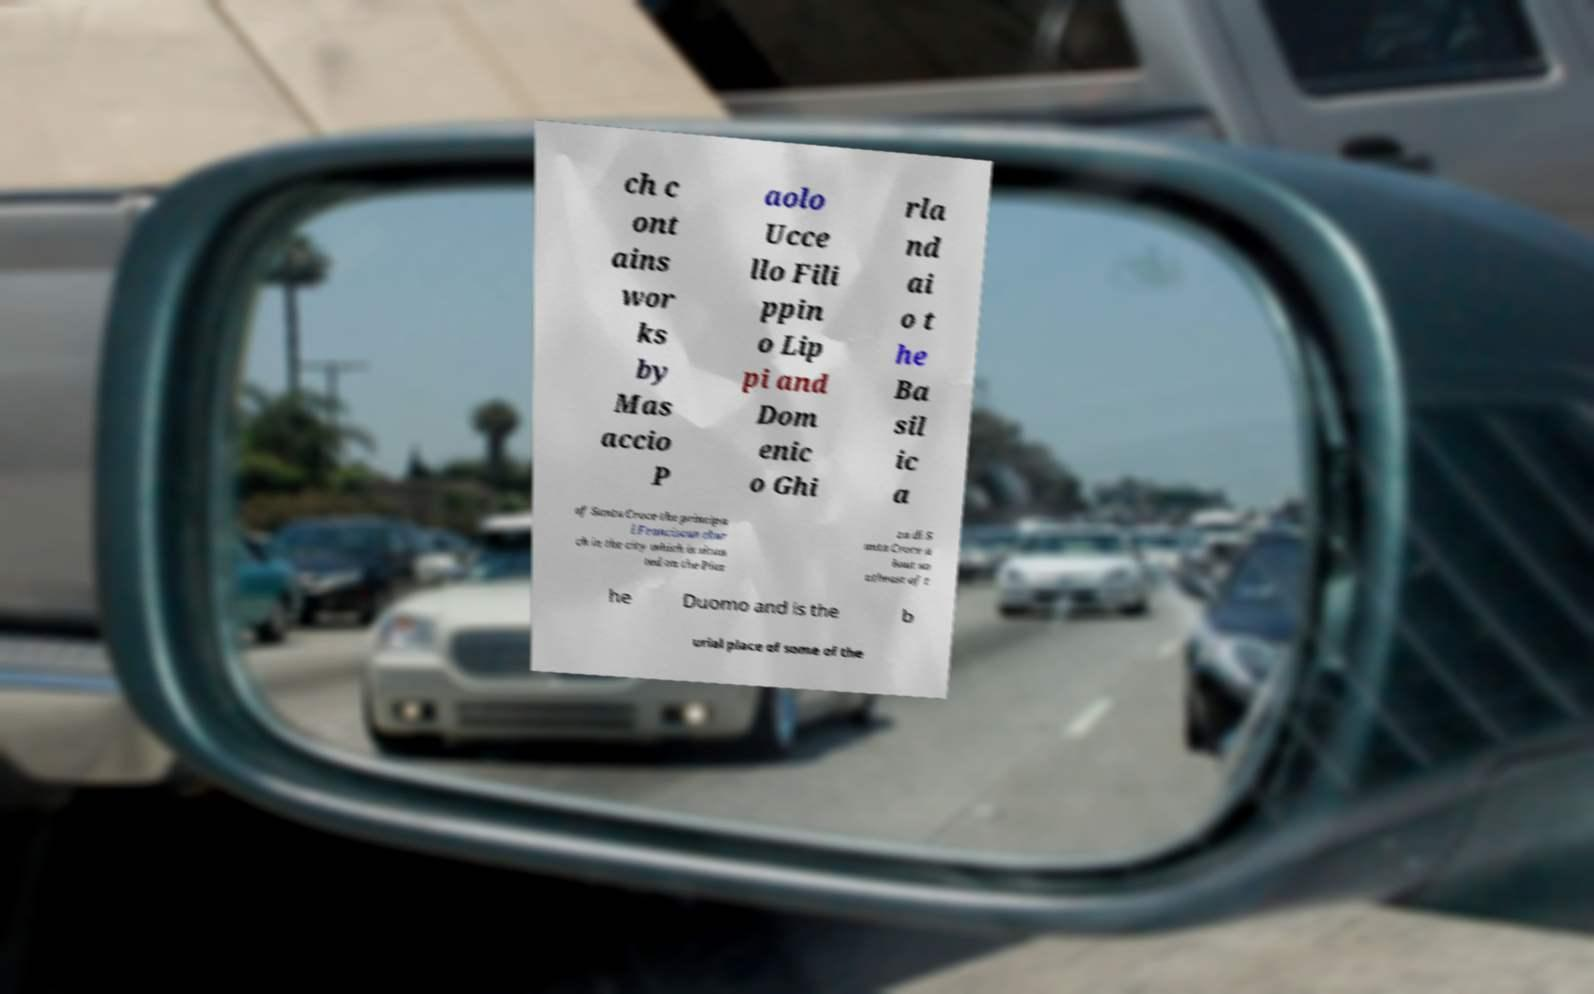For documentation purposes, I need the text within this image transcribed. Could you provide that? ch c ont ains wor ks by Mas accio P aolo Ucce llo Fili ppin o Lip pi and Dom enic o Ghi rla nd ai o t he Ba sil ic a of Santa Croce the principa l Franciscan chur ch in the city which is situa ted on the Piaz za di S anta Croce a bout so utheast of t he Duomo and is the b urial place of some of the 